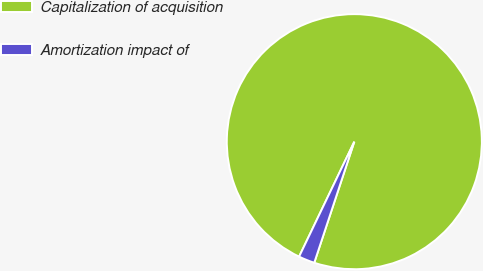Convert chart. <chart><loc_0><loc_0><loc_500><loc_500><pie_chart><fcel>Capitalization of acquisition<fcel>Amortization impact of<nl><fcel>97.96%<fcel>2.04%<nl></chart> 